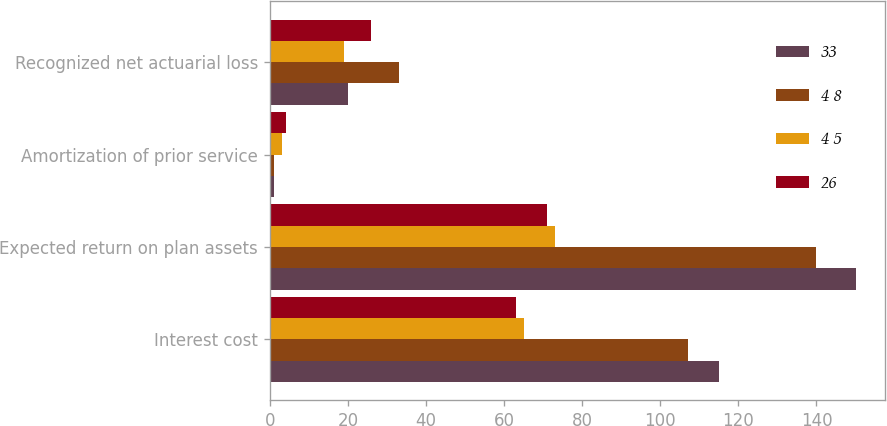Convert chart. <chart><loc_0><loc_0><loc_500><loc_500><stacked_bar_chart><ecel><fcel>Interest cost<fcel>Expected return on plan assets<fcel>Amortization of prior service<fcel>Recognized net actuarial loss<nl><fcel>33<fcel>115<fcel>150<fcel>1<fcel>20<nl><fcel>4 8<fcel>107<fcel>140<fcel>1<fcel>33<nl><fcel>4 5<fcel>65<fcel>73<fcel>3<fcel>19<nl><fcel>26<fcel>63<fcel>71<fcel>4<fcel>26<nl></chart> 